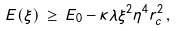Convert formula to latex. <formula><loc_0><loc_0><loc_500><loc_500>E ( \xi ) \, \geq \, E _ { 0 } - \kappa \lambda \xi ^ { 2 } \eta ^ { 4 } r _ { c } ^ { 2 } \, ,</formula> 